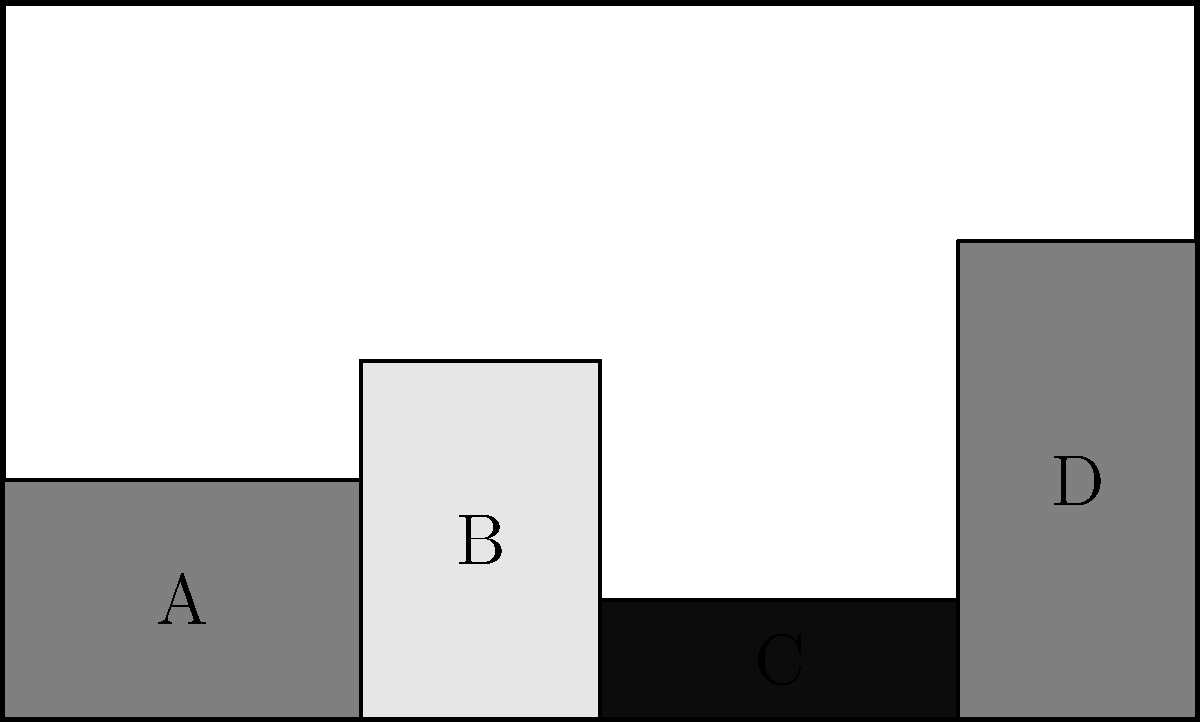You need to arrange four pieces of gym equipment (A, B, C, and D) in a storage space measuring 10 units wide and 6 units high. Given the arrangement shown, what is the total area of unused space in square units? To find the total area of unused space, we need to:

1. Calculate the total area of the storage space:
   Area = Width × Height = 10 × 6 = 60 square units

2. Calculate the area of each piece of equipment:
   A: 3 × 2 = 6 square units
   B: 2 × 3 = 6 square units
   C: 3 × 1 = 3 square units
   D: 2 × 4 = 8 square units

3. Sum up the total area occupied by equipment:
   Total occupied area = 6 + 6 + 3 + 8 = 23 square units

4. Subtract the occupied area from the total storage area:
   Unused space = Total area - Occupied area
   Unused space = 60 - 23 = 37 square units

Therefore, the total area of unused space is 37 square units.
Answer: 37 square units 